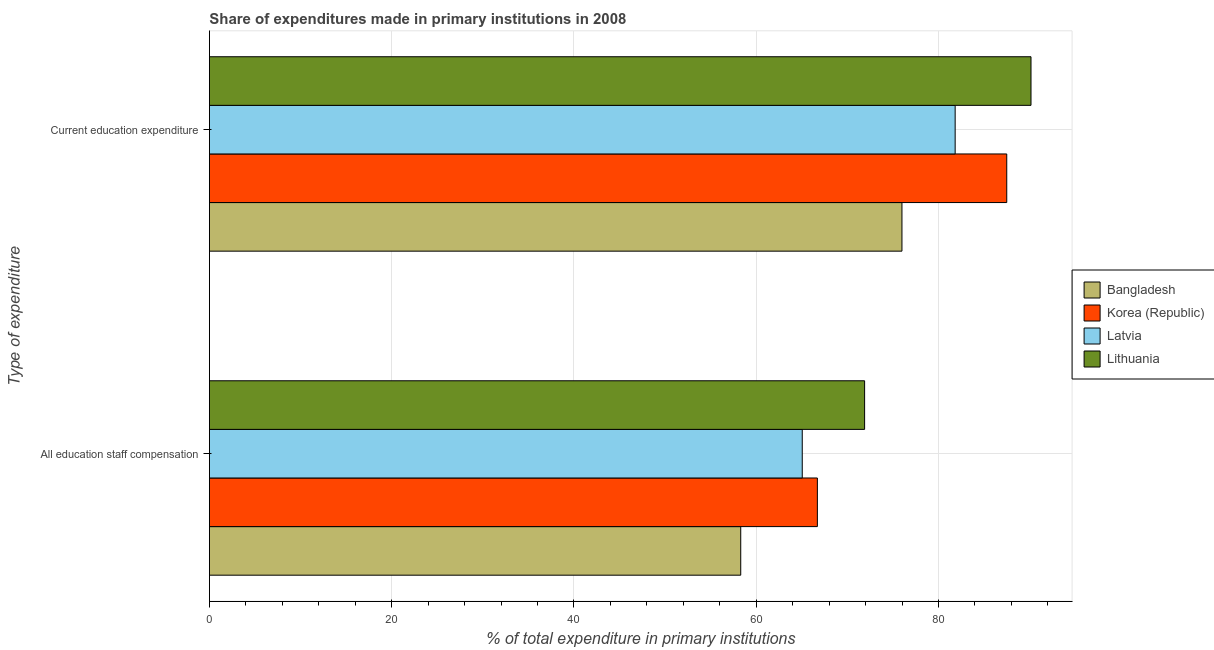How many different coloured bars are there?
Give a very brief answer. 4. Are the number of bars per tick equal to the number of legend labels?
Provide a succinct answer. Yes. Are the number of bars on each tick of the Y-axis equal?
Your answer should be very brief. Yes. What is the label of the 1st group of bars from the top?
Give a very brief answer. Current education expenditure. What is the expenditure in staff compensation in Bangladesh?
Offer a terse response. 58.3. Across all countries, what is the maximum expenditure in staff compensation?
Provide a succinct answer. 71.89. Across all countries, what is the minimum expenditure in education?
Offer a terse response. 75.99. In which country was the expenditure in education maximum?
Give a very brief answer. Lithuania. In which country was the expenditure in education minimum?
Ensure brevity in your answer.  Bangladesh. What is the total expenditure in education in the graph?
Your answer should be compact. 335.44. What is the difference between the expenditure in education in Bangladesh and that in Latvia?
Give a very brief answer. -5.84. What is the difference between the expenditure in education in Lithuania and the expenditure in staff compensation in Bangladesh?
Keep it short and to the point. 31.85. What is the average expenditure in education per country?
Your answer should be compact. 83.86. What is the difference between the expenditure in staff compensation and expenditure in education in Latvia?
Provide a succinct answer. -16.78. What is the ratio of the expenditure in education in Latvia to that in Bangladesh?
Your answer should be compact. 1.08. What does the 1st bar from the top in All education staff compensation represents?
Make the answer very short. Lithuania. Are all the bars in the graph horizontal?
Offer a terse response. Yes. Does the graph contain grids?
Give a very brief answer. Yes. Where does the legend appear in the graph?
Make the answer very short. Center right. How are the legend labels stacked?
Provide a succinct answer. Vertical. What is the title of the graph?
Provide a short and direct response. Share of expenditures made in primary institutions in 2008. Does "Turkmenistan" appear as one of the legend labels in the graph?
Offer a very short reply. No. What is the label or title of the X-axis?
Offer a terse response. % of total expenditure in primary institutions. What is the label or title of the Y-axis?
Offer a very short reply. Type of expenditure. What is the % of total expenditure in primary institutions in Bangladesh in All education staff compensation?
Offer a terse response. 58.3. What is the % of total expenditure in primary institutions of Korea (Republic) in All education staff compensation?
Offer a terse response. 66.71. What is the % of total expenditure in primary institutions of Latvia in All education staff compensation?
Offer a very short reply. 65.05. What is the % of total expenditure in primary institutions in Lithuania in All education staff compensation?
Make the answer very short. 71.89. What is the % of total expenditure in primary institutions of Bangladesh in Current education expenditure?
Offer a terse response. 75.99. What is the % of total expenditure in primary institutions of Korea (Republic) in Current education expenditure?
Provide a short and direct response. 87.49. What is the % of total expenditure in primary institutions in Latvia in Current education expenditure?
Give a very brief answer. 81.82. What is the % of total expenditure in primary institutions in Lithuania in Current education expenditure?
Offer a very short reply. 90.15. Across all Type of expenditure, what is the maximum % of total expenditure in primary institutions in Bangladesh?
Provide a succinct answer. 75.99. Across all Type of expenditure, what is the maximum % of total expenditure in primary institutions of Korea (Republic)?
Make the answer very short. 87.49. Across all Type of expenditure, what is the maximum % of total expenditure in primary institutions in Latvia?
Make the answer very short. 81.82. Across all Type of expenditure, what is the maximum % of total expenditure in primary institutions in Lithuania?
Offer a very short reply. 90.15. Across all Type of expenditure, what is the minimum % of total expenditure in primary institutions in Bangladesh?
Give a very brief answer. 58.3. Across all Type of expenditure, what is the minimum % of total expenditure in primary institutions in Korea (Republic)?
Provide a succinct answer. 66.71. Across all Type of expenditure, what is the minimum % of total expenditure in primary institutions of Latvia?
Ensure brevity in your answer.  65.05. Across all Type of expenditure, what is the minimum % of total expenditure in primary institutions in Lithuania?
Your answer should be compact. 71.89. What is the total % of total expenditure in primary institutions in Bangladesh in the graph?
Ensure brevity in your answer.  134.28. What is the total % of total expenditure in primary institutions in Korea (Republic) in the graph?
Keep it short and to the point. 154.19. What is the total % of total expenditure in primary institutions of Latvia in the graph?
Ensure brevity in your answer.  146.87. What is the total % of total expenditure in primary institutions in Lithuania in the graph?
Provide a succinct answer. 162.03. What is the difference between the % of total expenditure in primary institutions of Bangladesh in All education staff compensation and that in Current education expenditure?
Make the answer very short. -17.69. What is the difference between the % of total expenditure in primary institutions of Korea (Republic) in All education staff compensation and that in Current education expenditure?
Make the answer very short. -20.78. What is the difference between the % of total expenditure in primary institutions in Latvia in All education staff compensation and that in Current education expenditure?
Make the answer very short. -16.78. What is the difference between the % of total expenditure in primary institutions of Lithuania in All education staff compensation and that in Current education expenditure?
Offer a terse response. -18.26. What is the difference between the % of total expenditure in primary institutions in Bangladesh in All education staff compensation and the % of total expenditure in primary institutions in Korea (Republic) in Current education expenditure?
Provide a succinct answer. -29.19. What is the difference between the % of total expenditure in primary institutions of Bangladesh in All education staff compensation and the % of total expenditure in primary institutions of Latvia in Current education expenditure?
Ensure brevity in your answer.  -23.53. What is the difference between the % of total expenditure in primary institutions of Bangladesh in All education staff compensation and the % of total expenditure in primary institutions of Lithuania in Current education expenditure?
Give a very brief answer. -31.85. What is the difference between the % of total expenditure in primary institutions in Korea (Republic) in All education staff compensation and the % of total expenditure in primary institutions in Latvia in Current education expenditure?
Provide a succinct answer. -15.12. What is the difference between the % of total expenditure in primary institutions of Korea (Republic) in All education staff compensation and the % of total expenditure in primary institutions of Lithuania in Current education expenditure?
Your response must be concise. -23.44. What is the difference between the % of total expenditure in primary institutions of Latvia in All education staff compensation and the % of total expenditure in primary institutions of Lithuania in Current education expenditure?
Your answer should be compact. -25.1. What is the average % of total expenditure in primary institutions in Bangladesh per Type of expenditure?
Keep it short and to the point. 67.14. What is the average % of total expenditure in primary institutions in Korea (Republic) per Type of expenditure?
Provide a succinct answer. 77.1. What is the average % of total expenditure in primary institutions of Latvia per Type of expenditure?
Offer a very short reply. 73.44. What is the average % of total expenditure in primary institutions in Lithuania per Type of expenditure?
Offer a terse response. 81.02. What is the difference between the % of total expenditure in primary institutions in Bangladesh and % of total expenditure in primary institutions in Korea (Republic) in All education staff compensation?
Your answer should be compact. -8.41. What is the difference between the % of total expenditure in primary institutions of Bangladesh and % of total expenditure in primary institutions of Latvia in All education staff compensation?
Make the answer very short. -6.75. What is the difference between the % of total expenditure in primary institutions of Bangladesh and % of total expenditure in primary institutions of Lithuania in All education staff compensation?
Your answer should be compact. -13.59. What is the difference between the % of total expenditure in primary institutions of Korea (Republic) and % of total expenditure in primary institutions of Latvia in All education staff compensation?
Offer a very short reply. 1.66. What is the difference between the % of total expenditure in primary institutions in Korea (Republic) and % of total expenditure in primary institutions in Lithuania in All education staff compensation?
Your answer should be compact. -5.18. What is the difference between the % of total expenditure in primary institutions in Latvia and % of total expenditure in primary institutions in Lithuania in All education staff compensation?
Provide a short and direct response. -6.84. What is the difference between the % of total expenditure in primary institutions of Bangladesh and % of total expenditure in primary institutions of Korea (Republic) in Current education expenditure?
Provide a short and direct response. -11.5. What is the difference between the % of total expenditure in primary institutions of Bangladesh and % of total expenditure in primary institutions of Latvia in Current education expenditure?
Your answer should be compact. -5.84. What is the difference between the % of total expenditure in primary institutions of Bangladesh and % of total expenditure in primary institutions of Lithuania in Current education expenditure?
Make the answer very short. -14.16. What is the difference between the % of total expenditure in primary institutions of Korea (Republic) and % of total expenditure in primary institutions of Latvia in Current education expenditure?
Your answer should be very brief. 5.66. What is the difference between the % of total expenditure in primary institutions of Korea (Republic) and % of total expenditure in primary institutions of Lithuania in Current education expenditure?
Provide a short and direct response. -2.66. What is the difference between the % of total expenditure in primary institutions of Latvia and % of total expenditure in primary institutions of Lithuania in Current education expenditure?
Offer a terse response. -8.32. What is the ratio of the % of total expenditure in primary institutions in Bangladesh in All education staff compensation to that in Current education expenditure?
Provide a succinct answer. 0.77. What is the ratio of the % of total expenditure in primary institutions of Korea (Republic) in All education staff compensation to that in Current education expenditure?
Offer a very short reply. 0.76. What is the ratio of the % of total expenditure in primary institutions in Latvia in All education staff compensation to that in Current education expenditure?
Provide a short and direct response. 0.8. What is the ratio of the % of total expenditure in primary institutions in Lithuania in All education staff compensation to that in Current education expenditure?
Keep it short and to the point. 0.8. What is the difference between the highest and the second highest % of total expenditure in primary institutions of Bangladesh?
Give a very brief answer. 17.69. What is the difference between the highest and the second highest % of total expenditure in primary institutions of Korea (Republic)?
Make the answer very short. 20.78. What is the difference between the highest and the second highest % of total expenditure in primary institutions of Latvia?
Make the answer very short. 16.78. What is the difference between the highest and the second highest % of total expenditure in primary institutions of Lithuania?
Provide a succinct answer. 18.26. What is the difference between the highest and the lowest % of total expenditure in primary institutions in Bangladesh?
Make the answer very short. 17.69. What is the difference between the highest and the lowest % of total expenditure in primary institutions in Korea (Republic)?
Your response must be concise. 20.78. What is the difference between the highest and the lowest % of total expenditure in primary institutions in Latvia?
Offer a very short reply. 16.78. What is the difference between the highest and the lowest % of total expenditure in primary institutions in Lithuania?
Your answer should be very brief. 18.26. 